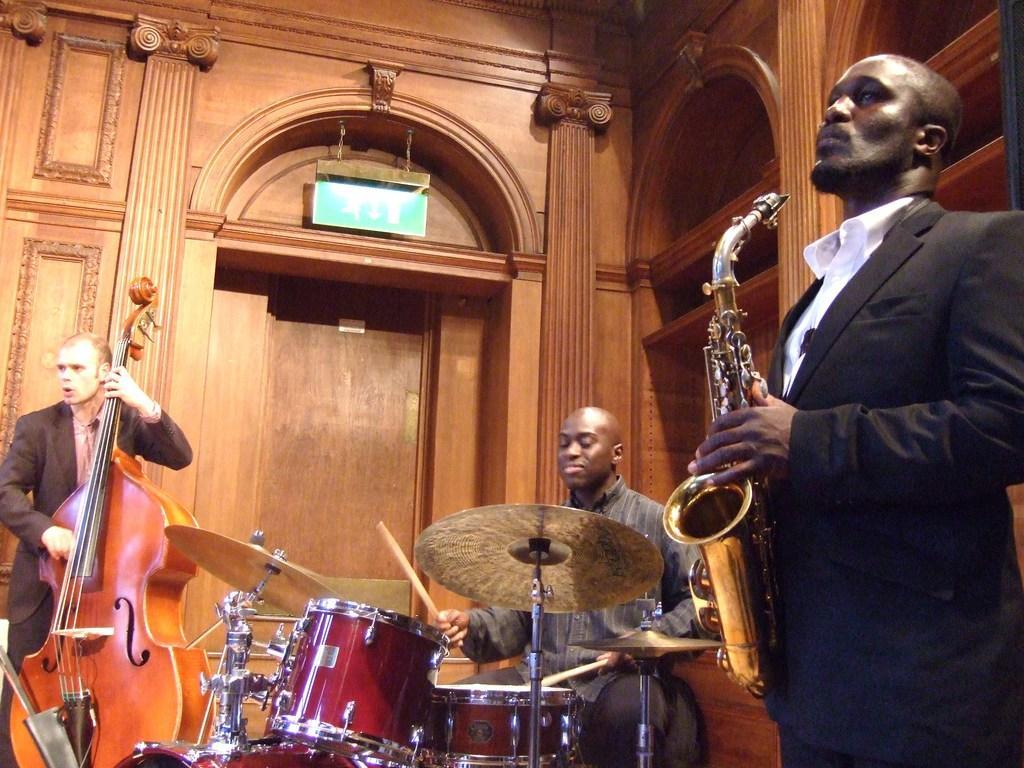How would you summarize this image in a sentence or two? In this image I can see a group of men are playing musical instruments. I can also see there is a drum 